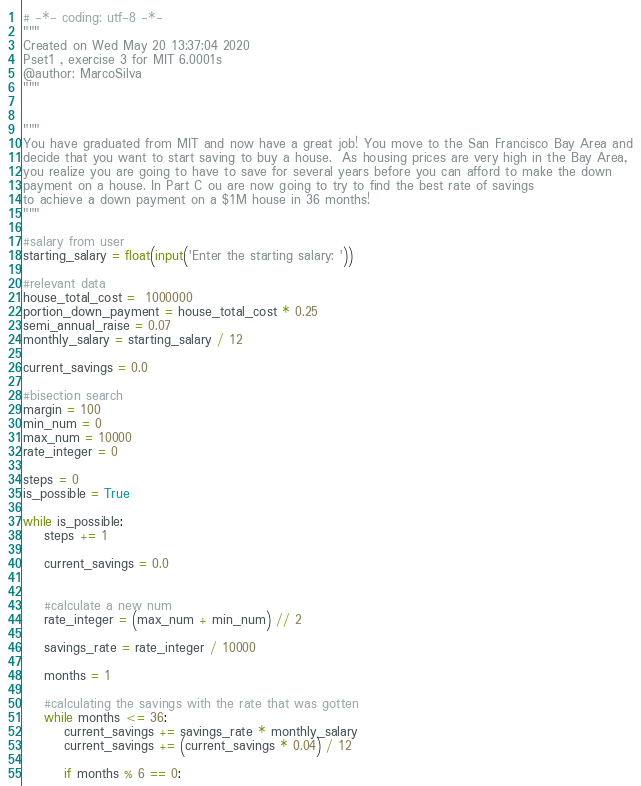<code> <loc_0><loc_0><loc_500><loc_500><_Python_># -*- coding: utf-8 -*-
"""
Created on Wed May 20 13:37:04 2020
Pset1 , exercise 3 for MIT 6.0001s
@author: MarcoSilva
"""


"""
You have graduated from MIT and now have a great job! You move to the San Francisco Bay Area and
decide that you want to start saving to buy a house.  As housing prices are very high in the Bay Area,
you realize you are going to have to save for several years before you can afford to make the down
payment on a house. In Part C ou are now going to try to find the best rate of savings 
to achieve a down payment on a $1M house in 36 months! 
"""

#salary from user
starting_salary = float(input('Enter the starting salary: '))

#relevant data
house_total_cost =  1000000 
portion_down_payment = house_total_cost * 0.25 
semi_annual_raise = 0.07 
monthly_salary = starting_salary / 12

current_savings = 0.0

#bisection search
margin = 100
min_num = 0
max_num = 10000
rate_integer = 0

steps = 0
is_possible = True

while is_possible:
    steps += 1
    
    current_savings = 0.0
    
        
    #calculate a new num    
    rate_integer = (max_num + min_num) // 2
    
    savings_rate = rate_integer / 10000
    
    months = 1
    
    #calculating the savings with the rate that was gotten
    while months <= 36:        
        current_savings += savings_rate * monthly_salary
        current_savings += (current_savings * 0.04) / 12
        
        if months % 6 == 0:</code> 